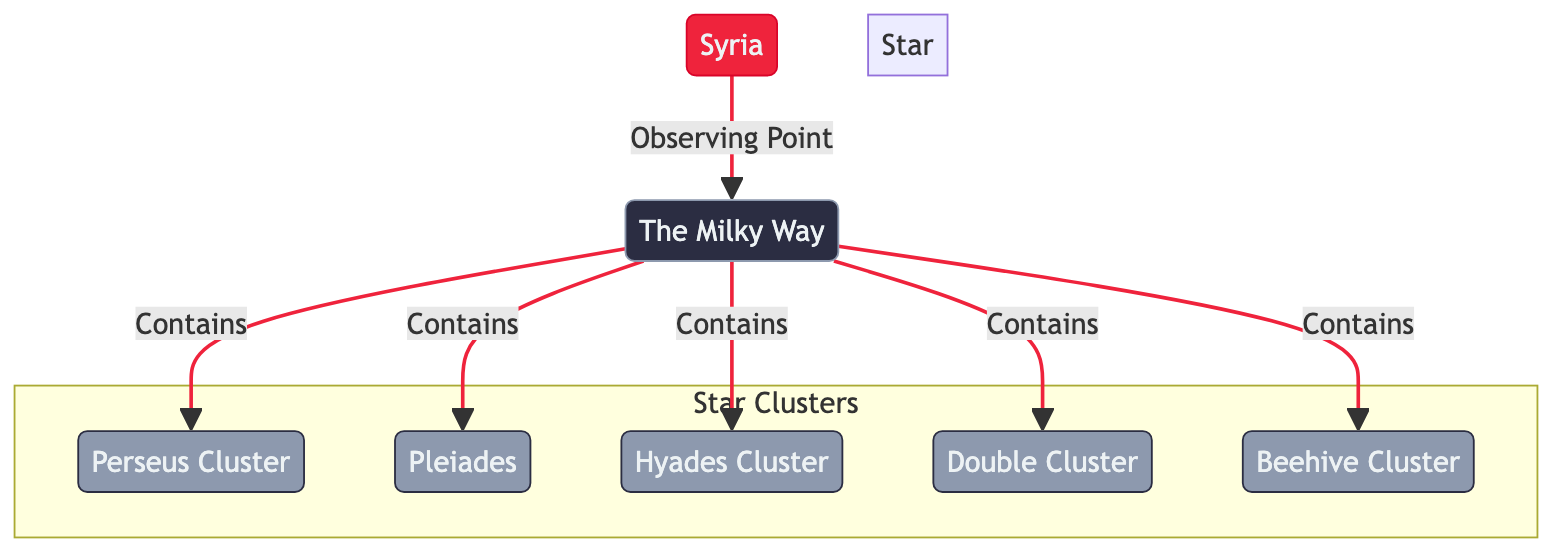What is the main galaxy depicted in the diagram? The diagram shows "The Milky Way" as the main galaxy, which is visually emphasized and labeled at the top of the diagram.
Answer: The Milky Way How many star clusters are mentioned in the diagram? There are five star clusters listed in the diagram: Perseus Cluster, Pleiades, Hyades Cluster, Double Cluster, and Beehive Cluster. Counting these clusters provides the total number.
Answer: 5 Which star cluster is directly connected to the Milky Way? The diagram indicates that Perseus Cluster, Pleiades, Hyades Cluster, Double Cluster, and Beehive Cluster all have direct connections to the Milky Way, as they are all shown as being contained within the Milky Way.
Answer: Perseus Cluster, Pleiades, Hyades Cluster, Double Cluster, Beehive Cluster What is the role of Syria in relation to the Milky Way? Syria is represented as the observing point for the Milky Way in the diagram, indicating that it is the location from which the Milky Way and its star clusters are observed.
Answer: Observing Point Which star cluster appears first in the diagram? The first star cluster listed in the diagram is the Perseus Cluster since it is the first one mentioned as being contained in the Milky Way. This can be identified by the flow of connections in the diagram.
Answer: Perseus Cluster What color is used to represent the star clusters in the diagram? The star clusters are represented in a shade of grayish blue, which can be observed in the color coding assigned to these elements in the diagram.
Answer: Grayish Blue Which cluster is the last one mentioned in the diagram? The last star cluster mentioned is the Beehive Cluster, as it is the final item listed under the connections from the Milky Way. This can be determined by the order of the clusters shown in their grouping.
Answer: Beehive Cluster What is the visual style of the Milky Way node? The Milky Way node is styled with larger font size and bold font-weight, making it visually distinct and prominent in the diagram as the main element.
Answer: Bold and Large Font How do the star clusters connect to the Milky Way in the diagram? Each star cluster is specifically connected to the Milky Way with directed edges indicating containment, showing that the Milky Way contains all listed star clusters.
Answer: Containment Connections 